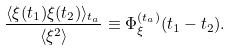Convert formula to latex. <formula><loc_0><loc_0><loc_500><loc_500>\frac { \langle \xi ( t _ { 1 } ) \xi ( t _ { 2 } ) \rangle _ { t _ { a } } } { \langle \xi ^ { 2 } \rangle } \equiv \Phi _ { \xi } ^ { ( t _ { a } ) } ( t _ { 1 } - t _ { 2 } ) .</formula> 